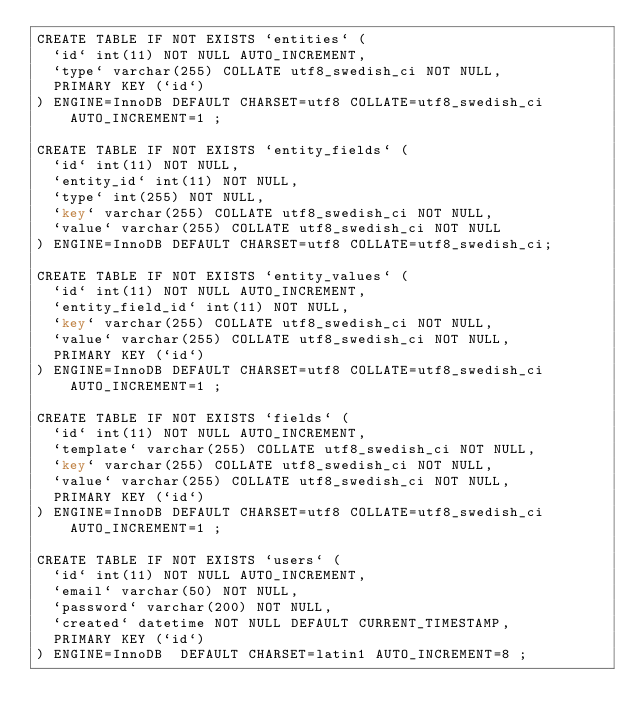Convert code to text. <code><loc_0><loc_0><loc_500><loc_500><_SQL_>CREATE TABLE IF NOT EXISTS `entities` (
  `id` int(11) NOT NULL AUTO_INCREMENT,
  `type` varchar(255) COLLATE utf8_swedish_ci NOT NULL,
  PRIMARY KEY (`id`)
) ENGINE=InnoDB DEFAULT CHARSET=utf8 COLLATE=utf8_swedish_ci AUTO_INCREMENT=1 ;

CREATE TABLE IF NOT EXISTS `entity_fields` (
  `id` int(11) NOT NULL,
  `entity_id` int(11) NOT NULL,
  `type` int(255) NOT NULL,
  `key` varchar(255) COLLATE utf8_swedish_ci NOT NULL,
  `value` varchar(255) COLLATE utf8_swedish_ci NOT NULL
) ENGINE=InnoDB DEFAULT CHARSET=utf8 COLLATE=utf8_swedish_ci;

CREATE TABLE IF NOT EXISTS `entity_values` (
  `id` int(11) NOT NULL AUTO_INCREMENT,
  `entity_field_id` int(11) NOT NULL,
  `key` varchar(255) COLLATE utf8_swedish_ci NOT NULL,
  `value` varchar(255) COLLATE utf8_swedish_ci NOT NULL,
  PRIMARY KEY (`id`)
) ENGINE=InnoDB DEFAULT CHARSET=utf8 COLLATE=utf8_swedish_ci AUTO_INCREMENT=1 ;

CREATE TABLE IF NOT EXISTS `fields` (
  `id` int(11) NOT NULL AUTO_INCREMENT,
  `template` varchar(255) COLLATE utf8_swedish_ci NOT NULL,
  `key` varchar(255) COLLATE utf8_swedish_ci NOT NULL,
  `value` varchar(255) COLLATE utf8_swedish_ci NOT NULL,
  PRIMARY KEY (`id`)
) ENGINE=InnoDB DEFAULT CHARSET=utf8 COLLATE=utf8_swedish_ci AUTO_INCREMENT=1 ;

CREATE TABLE IF NOT EXISTS `users` (
  `id` int(11) NOT NULL AUTO_INCREMENT,
  `email` varchar(50) NOT NULL,
  `password` varchar(200) NOT NULL,
  `created` datetime NOT NULL DEFAULT CURRENT_TIMESTAMP,
  PRIMARY KEY (`id`)
) ENGINE=InnoDB  DEFAULT CHARSET=latin1 AUTO_INCREMENT=8 ;
</code> 